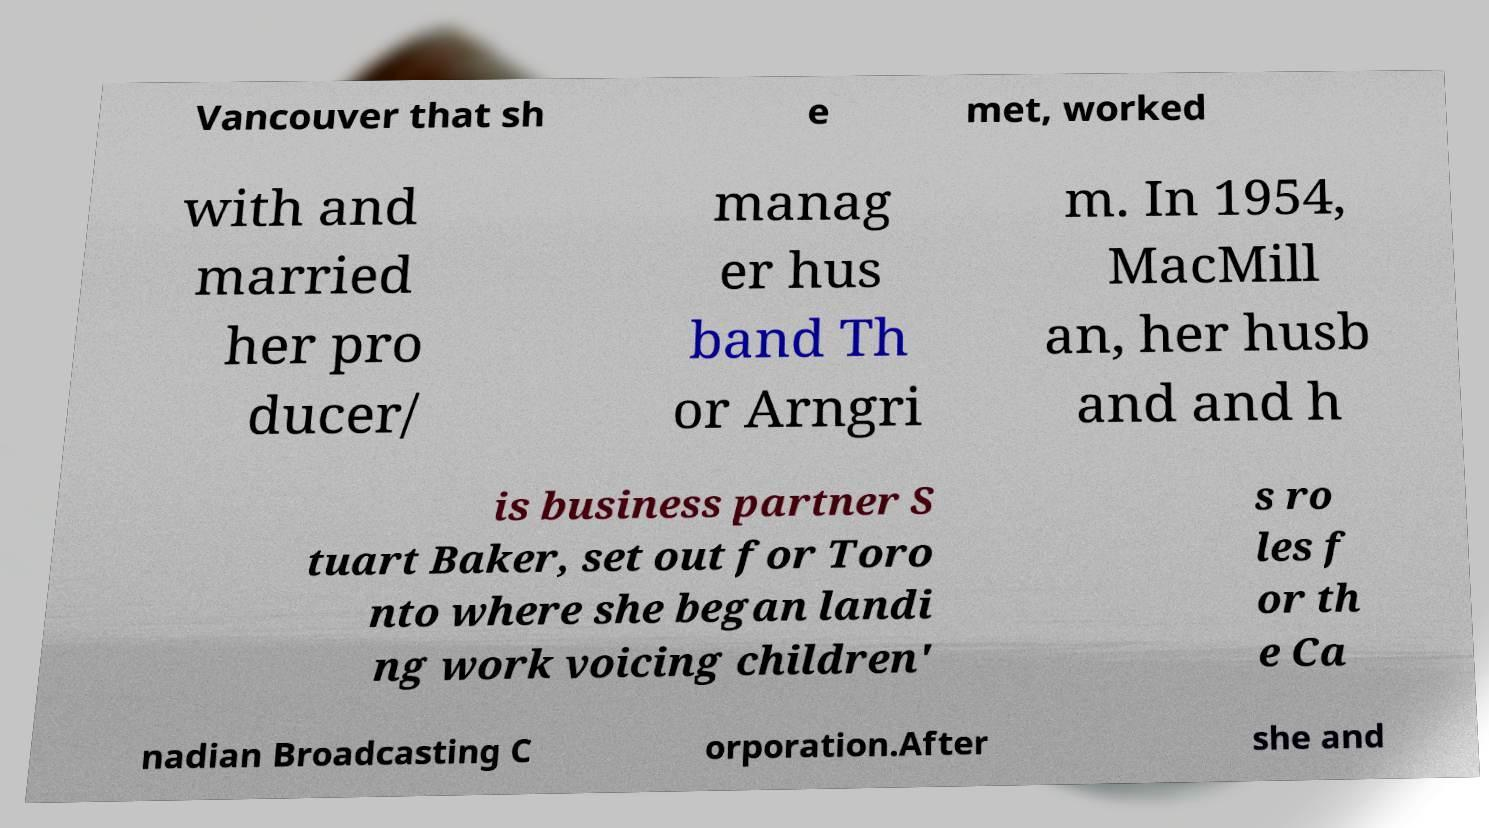Can you read and provide the text displayed in the image?This photo seems to have some interesting text. Can you extract and type it out for me? Vancouver that sh e met, worked with and married her pro ducer/ manag er hus band Th or Arngri m. In 1954, MacMill an, her husb and and h is business partner S tuart Baker, set out for Toro nto where she began landi ng work voicing children' s ro les f or th e Ca nadian Broadcasting C orporation.After she and 